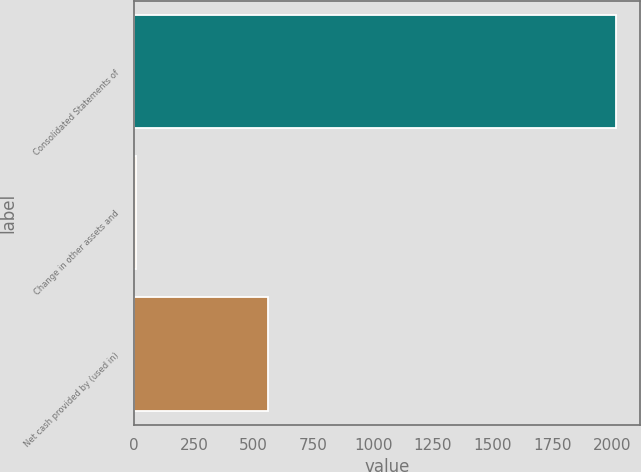Convert chart. <chart><loc_0><loc_0><loc_500><loc_500><bar_chart><fcel>Consolidated Statements of<fcel>Change in other assets and<fcel>Net cash provided by (used in)<nl><fcel>2015<fcel>8.9<fcel>561.6<nl></chart> 